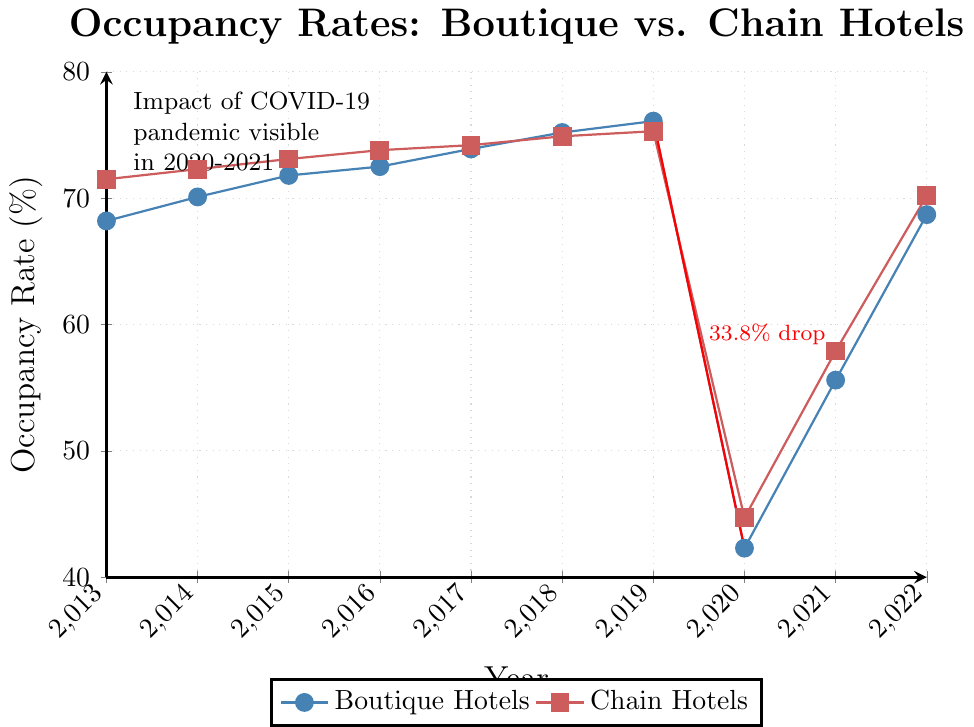What is the significant event indicated on the chart and its impact on occupancy rates? The chart highlights the impact of the COVID-19 pandemic in 2020-2021, showing a considerable drop in occupancy rates for both boutique and chain hotels. For boutique hotels, the rate dropped from 76.1% in 2019 to 42.3% in 2020.
Answer: COVID-19 pandemic; drop in occupancy rates By how much did the occupancy rate for boutique hotels decrease from 2019 to 2020? We note from the chart that the occupancy rate for boutique hotels decreased from 76.1% in 2019 to 42.3% in 2020. The difference is calculated as 76.1 - 42.3.
Answer: 33.8% Which type of hotel had a higher occupancy rate in 2022? The chart shows that the occupancy rate for boutique hotels in 2022 was 68.7%, and for chain hotels, it was 70.2%. Comparing the two values, we see that chain hotels had a higher occupancy rate.
Answer: Chain hotels What was the average occupancy rate of boutique hotels over the entire decade? To find the average occupancy rate for boutique hotels, we sum all the provided values for each year (68.2 + 70.1 + 71.8 + 72.5 + 73.9 + 75.2 + 76.1 + 42.3 + 55.6 + 68.7) and divide by the number of years (10).
Answer: 67.44% Between which consecutive years did boutique hotels see the highest increase in occupancy rate? By examining the year-on-year changes: 
- 2013-2014: 70.1 - 68.2 = 1.9
- 2014-2015: 71.8 - 70.1 = 1.7
- 2015-2016: 72.5 - 71.8 = 0.7
- 2016-2017: 73.9 - 72.5 = 1.4
- 2017-2018: 75.2 - 73.9 = 1.3
- 2018-2019: 76.1 - 75.2 = 0.9
- 2019-2020: 42.3 - 76.1 = -33.8
- 2020-2021: 55.6 - 42.3 = 13.3
- 2021-2022: 68.7 - 55.6 = 13.1
The largest positive increase is from 2020 to 2021, with an increase of 13.3%.
Answer: 2020-2021 By what percentage is the boutique hotels' occupancy rate higher or lower in 2022 compared to 2013? We calculate the percentage change using the formula [(final value - initial value) / initial value] * 100. So, for boutique hotels, it is [(68.7-68.2)/68.2]*100.
Answer: 0.73% higher 